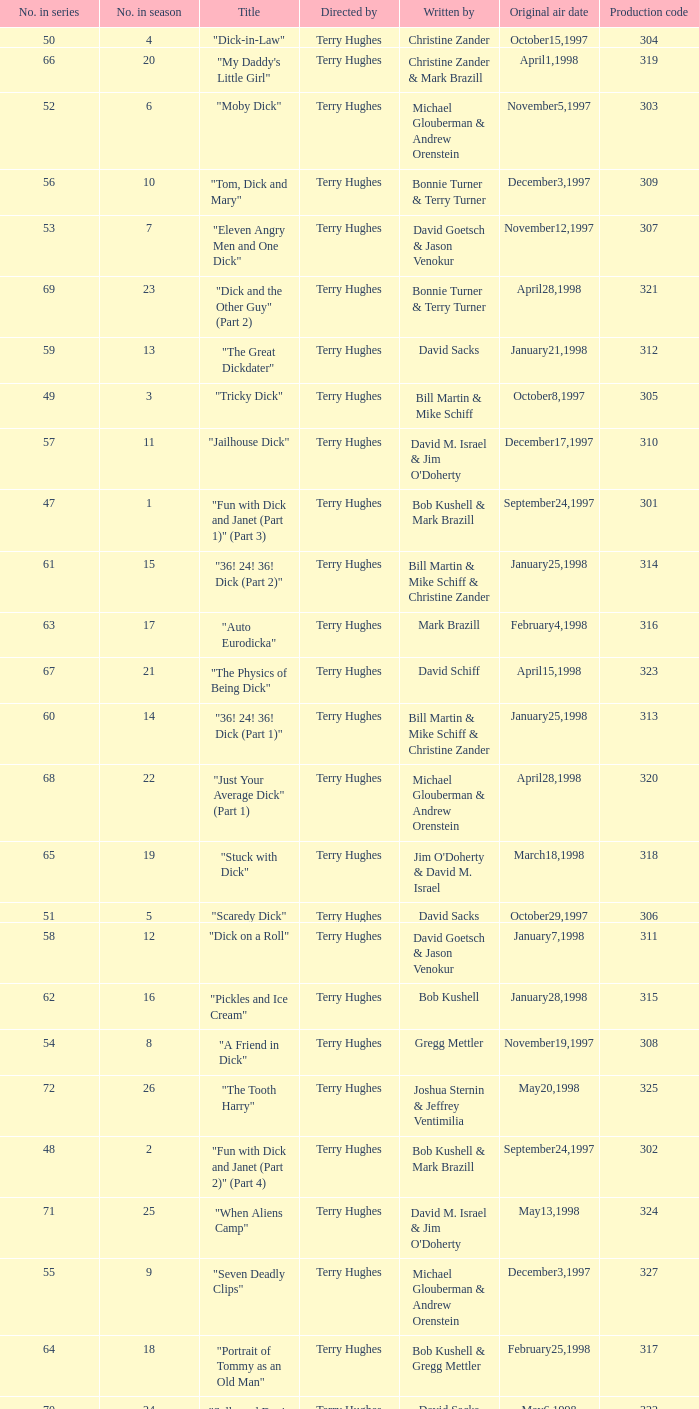What is the title of episode 10? "Tom, Dick and Mary". 